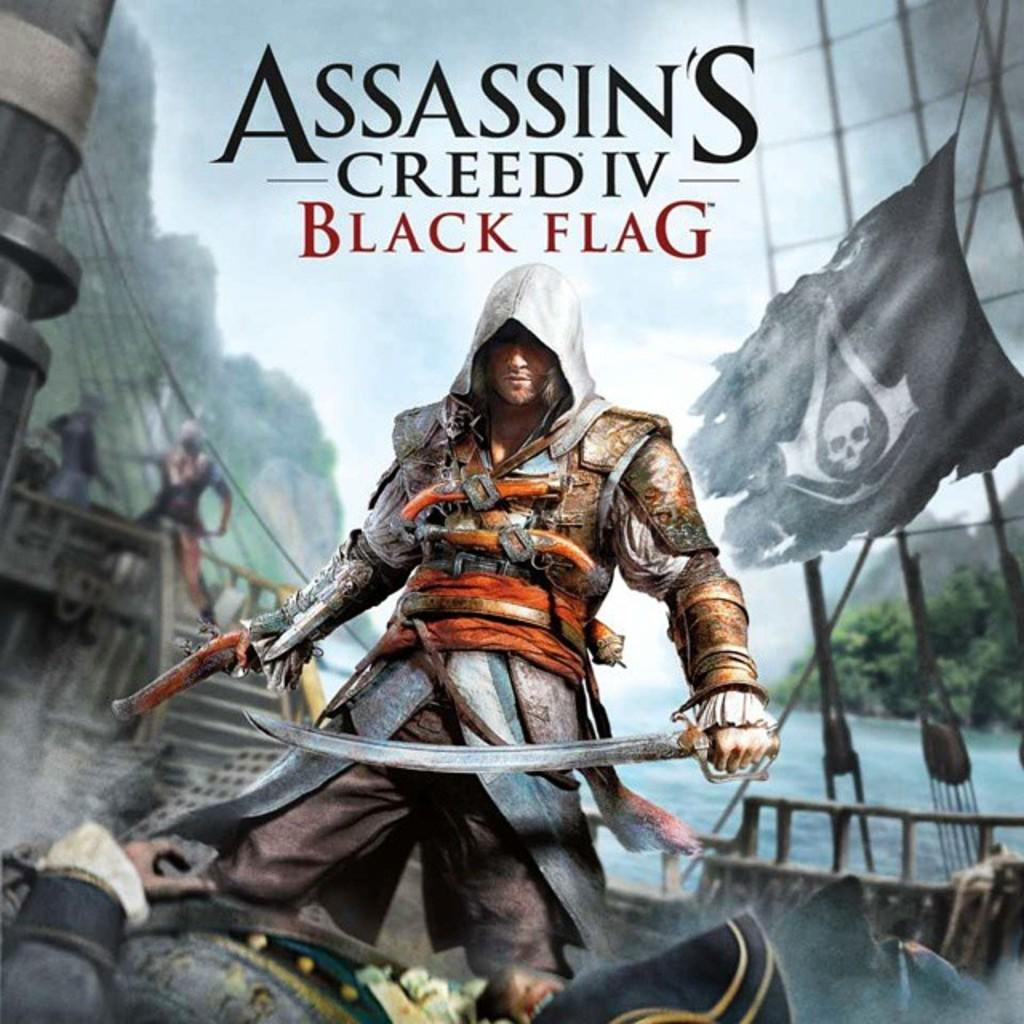<image>
Relay a brief, clear account of the picture shown. An advertisement of Assassin's Creed IV Black Flag features a man with a sword. 